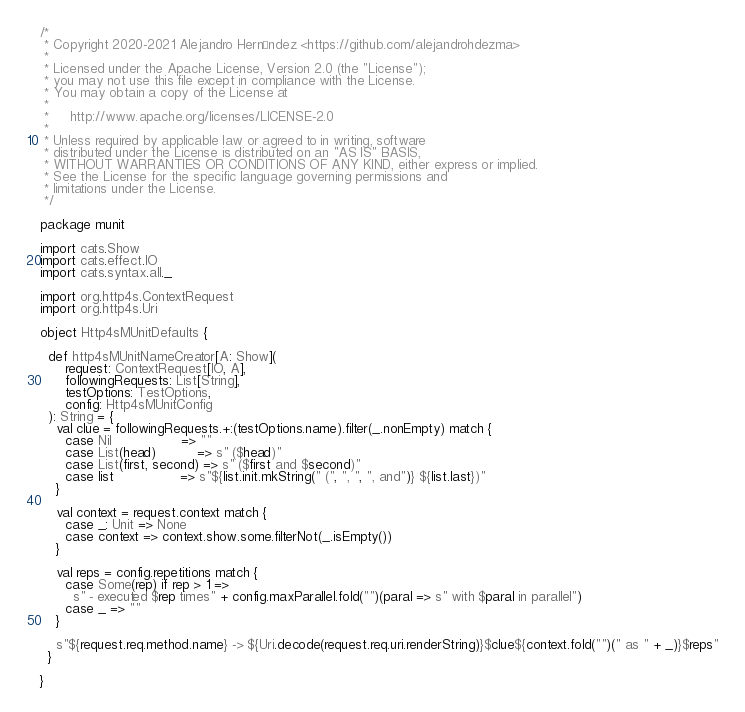<code> <loc_0><loc_0><loc_500><loc_500><_Scala_>/*
 * Copyright 2020-2021 Alejandro Hernández <https://github.com/alejandrohdezma>
 *
 * Licensed under the Apache License, Version 2.0 (the "License");
 * you may not use this file except in compliance with the License.
 * You may obtain a copy of the License at
 *
 *     http://www.apache.org/licenses/LICENSE-2.0
 *
 * Unless required by applicable law or agreed to in writing, software
 * distributed under the License is distributed on an "AS IS" BASIS,
 * WITHOUT WARRANTIES OR CONDITIONS OF ANY KIND, either express or implied.
 * See the License for the specific language governing permissions and
 * limitations under the License.
 */

package munit

import cats.Show
import cats.effect.IO
import cats.syntax.all._

import org.http4s.ContextRequest
import org.http4s.Uri

object Http4sMUnitDefaults {

  def http4sMUnitNameCreator[A: Show](
      request: ContextRequest[IO, A],
      followingRequests: List[String],
      testOptions: TestOptions,
      config: Http4sMUnitConfig
  ): String = {
    val clue = followingRequests.+:(testOptions.name).filter(_.nonEmpty) match {
      case Nil                 => ""
      case List(head)          => s" ($head)"
      case List(first, second) => s" ($first and $second)"
      case list                => s"${list.init.mkString(" (", ", ", ", and")} ${list.last})"
    }

    val context = request.context match {
      case _: Unit => None
      case context => context.show.some.filterNot(_.isEmpty())
    }

    val reps = config.repetitions match {
      case Some(rep) if rep > 1 =>
        s" - executed $rep times" + config.maxParallel.fold("")(paral => s" with $paral in parallel")
      case _ => ""
    }

    s"${request.req.method.name} -> ${Uri.decode(request.req.uri.renderString)}$clue${context.fold("")(" as " + _)}$reps"
  }

}
</code> 